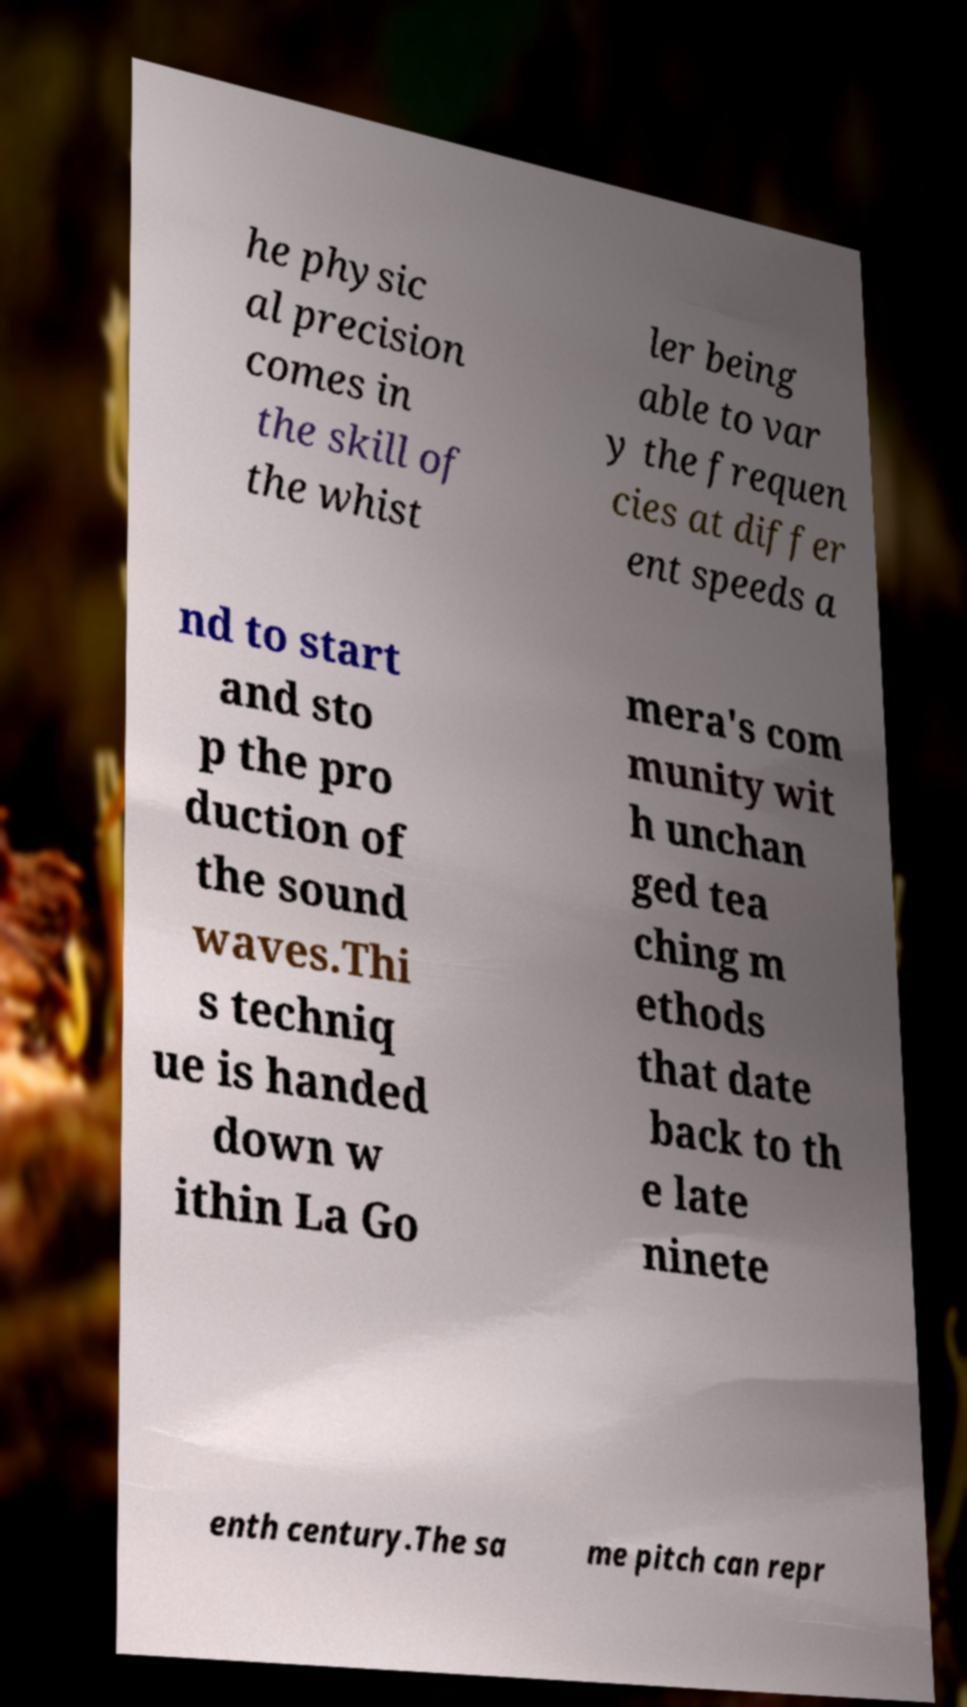For documentation purposes, I need the text within this image transcribed. Could you provide that? he physic al precision comes in the skill of the whist ler being able to var y the frequen cies at differ ent speeds a nd to start and sto p the pro duction of the sound waves.Thi s techniq ue is handed down w ithin La Go mera's com munity wit h unchan ged tea ching m ethods that date back to th e late ninete enth century.The sa me pitch can repr 